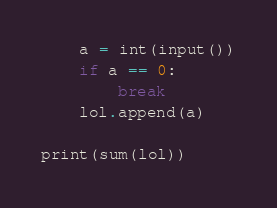<code> <loc_0><loc_0><loc_500><loc_500><_Python_>    a = int(input())
    if a == 0:
        break
    lol.append(a)

print(sum(lol))
</code> 